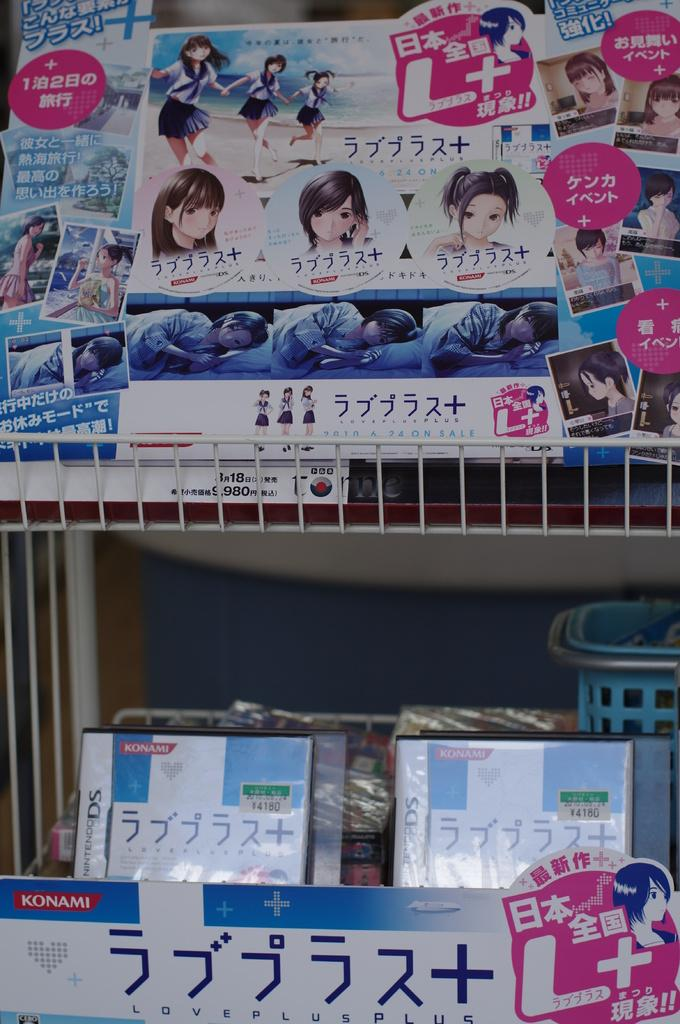What type of furniture is present in the image? There is a shelf in the image. What can be seen on the shelf? There are many posters with text in the image. How does the shelf fold in the image? The shelf does not fold in the image; it is a stationary piece of furniture. 